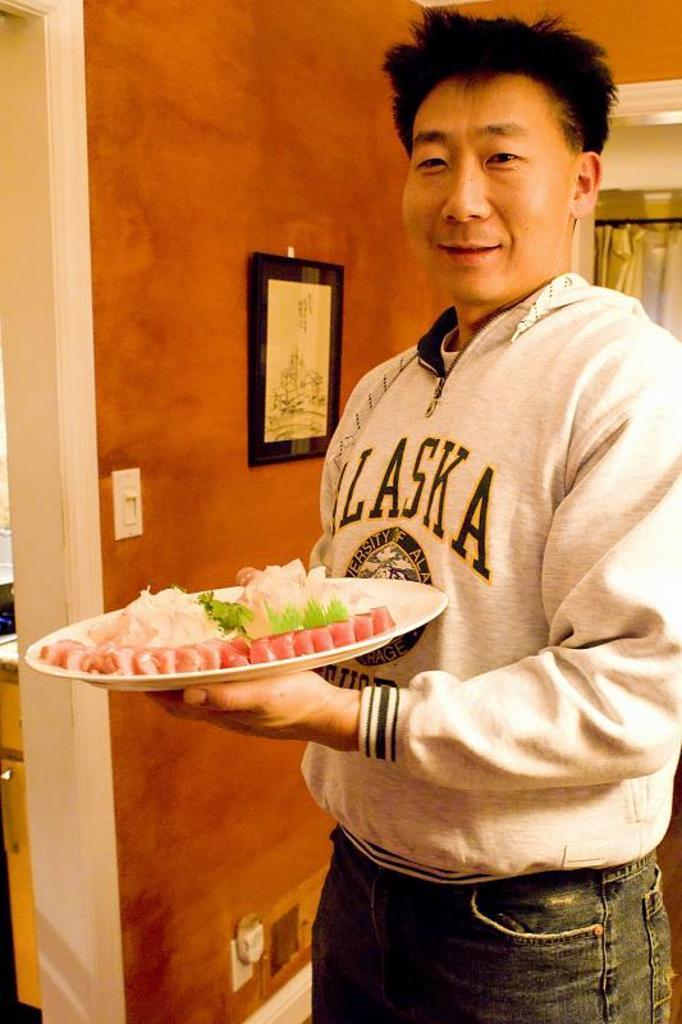Describe this image in one or two sentences. This is the picture of a room. In this image there is a person standing and holding the plate and there is a food on the plate. On the left side of the image there is a cupboard. There are frames and there is a switch board on the wall. At the back there is a curtain. 